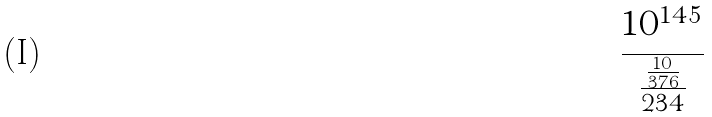Convert formula to latex. <formula><loc_0><loc_0><loc_500><loc_500>\frac { 1 0 ^ { 1 4 5 } } { \frac { \frac { 1 0 } { 3 7 6 } } { 2 3 4 } }</formula> 